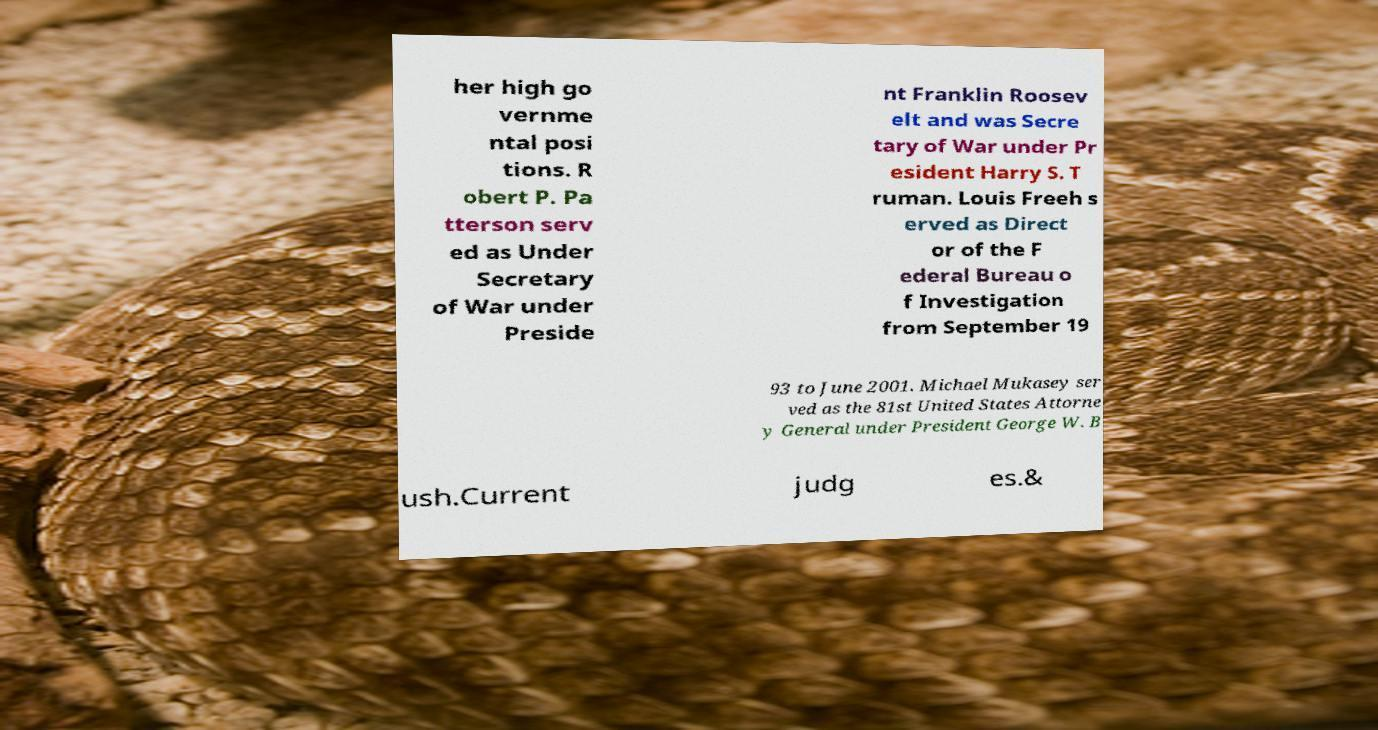What messages or text are displayed in this image? I need them in a readable, typed format. her high go vernme ntal posi tions. R obert P. Pa tterson serv ed as Under Secretary of War under Preside nt Franklin Roosev elt and was Secre tary of War under Pr esident Harry S. T ruman. Louis Freeh s erved as Direct or of the F ederal Bureau o f Investigation from September 19 93 to June 2001. Michael Mukasey ser ved as the 81st United States Attorne y General under President George W. B ush.Current judg es.& 